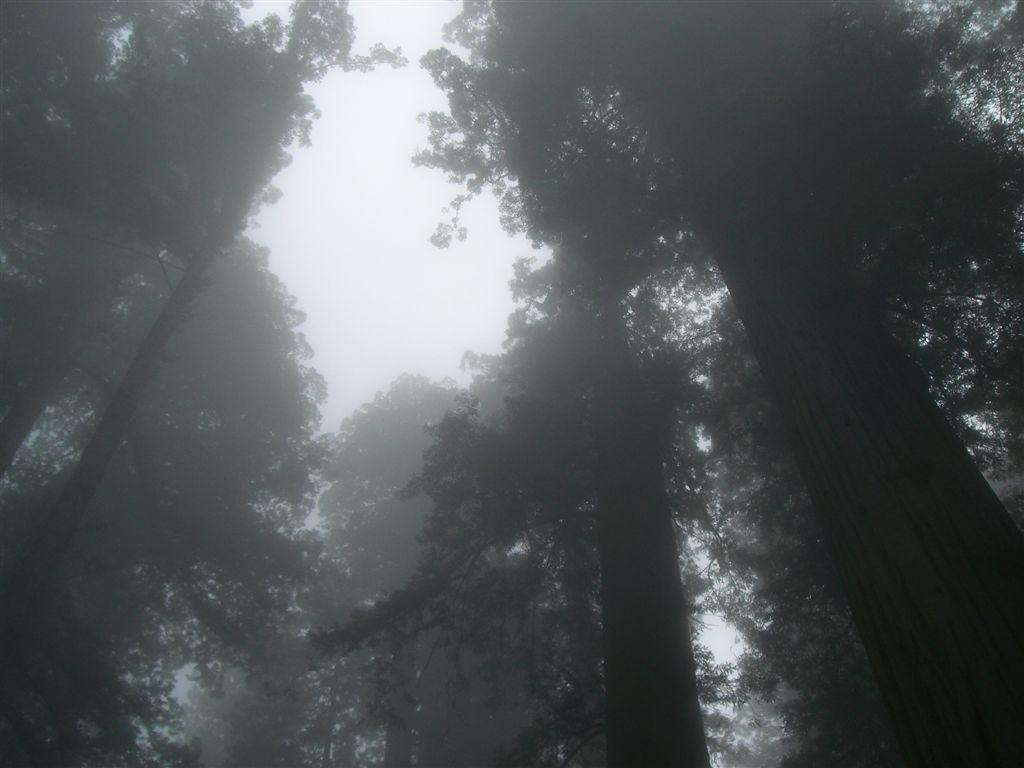In one or two sentences, can you explain what this image depicts? In this picture we can see trees and the sky. 